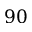<formula> <loc_0><loc_0><loc_500><loc_500>9 0</formula> 